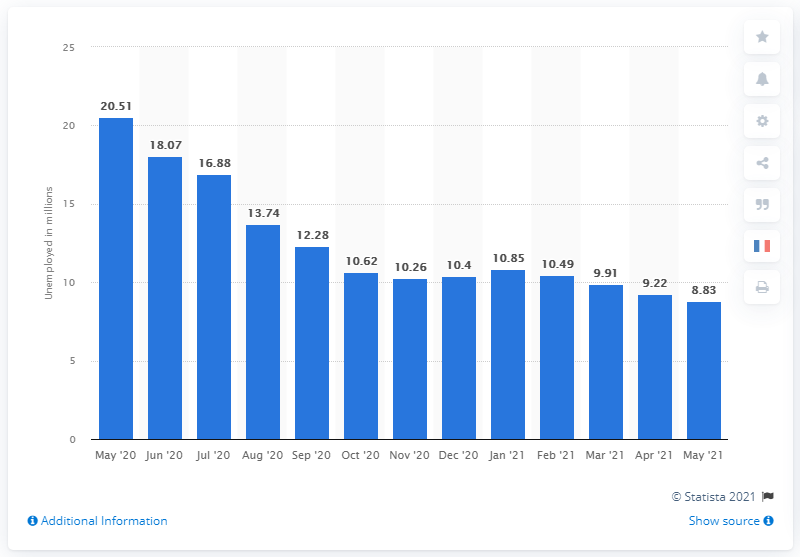Point out several critical features in this image. In May 2021, there were 8.83 million people in the United States who were unemployed and actively seeking employment. 